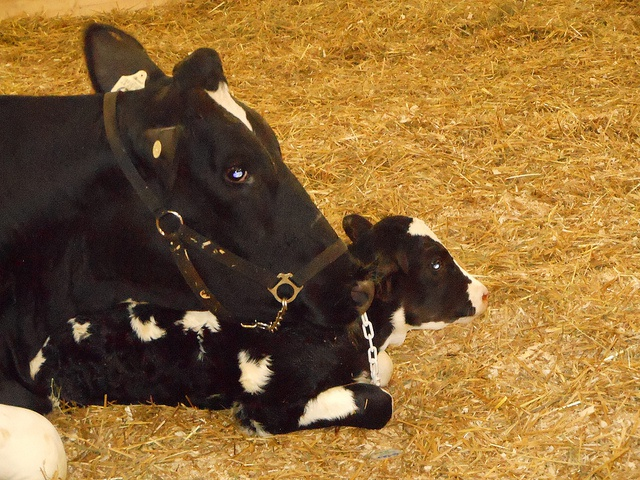Describe the objects in this image and their specific colors. I can see cow in orange, black, maroon, and tan tones and cow in orange, black, tan, maroon, and beige tones in this image. 